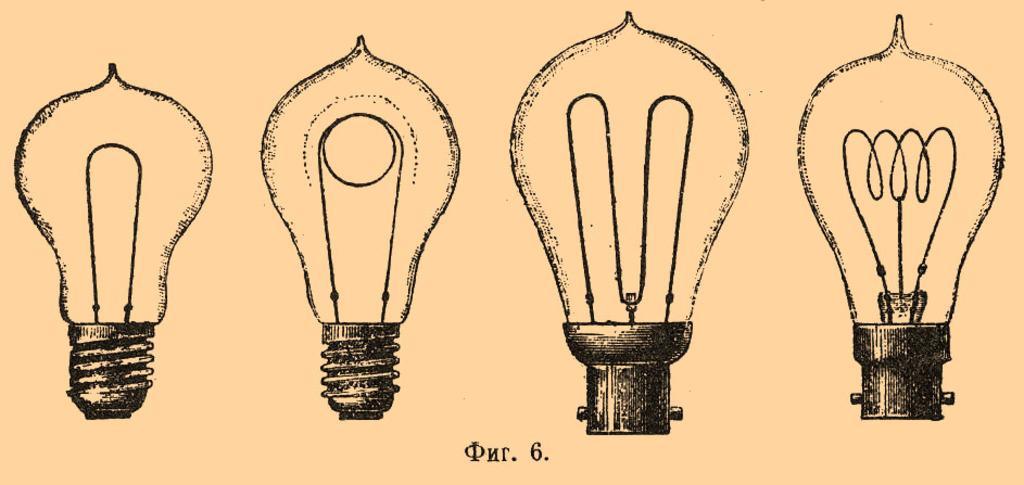Can you describe this image briefly? In this image we can paintings of the bulb. 